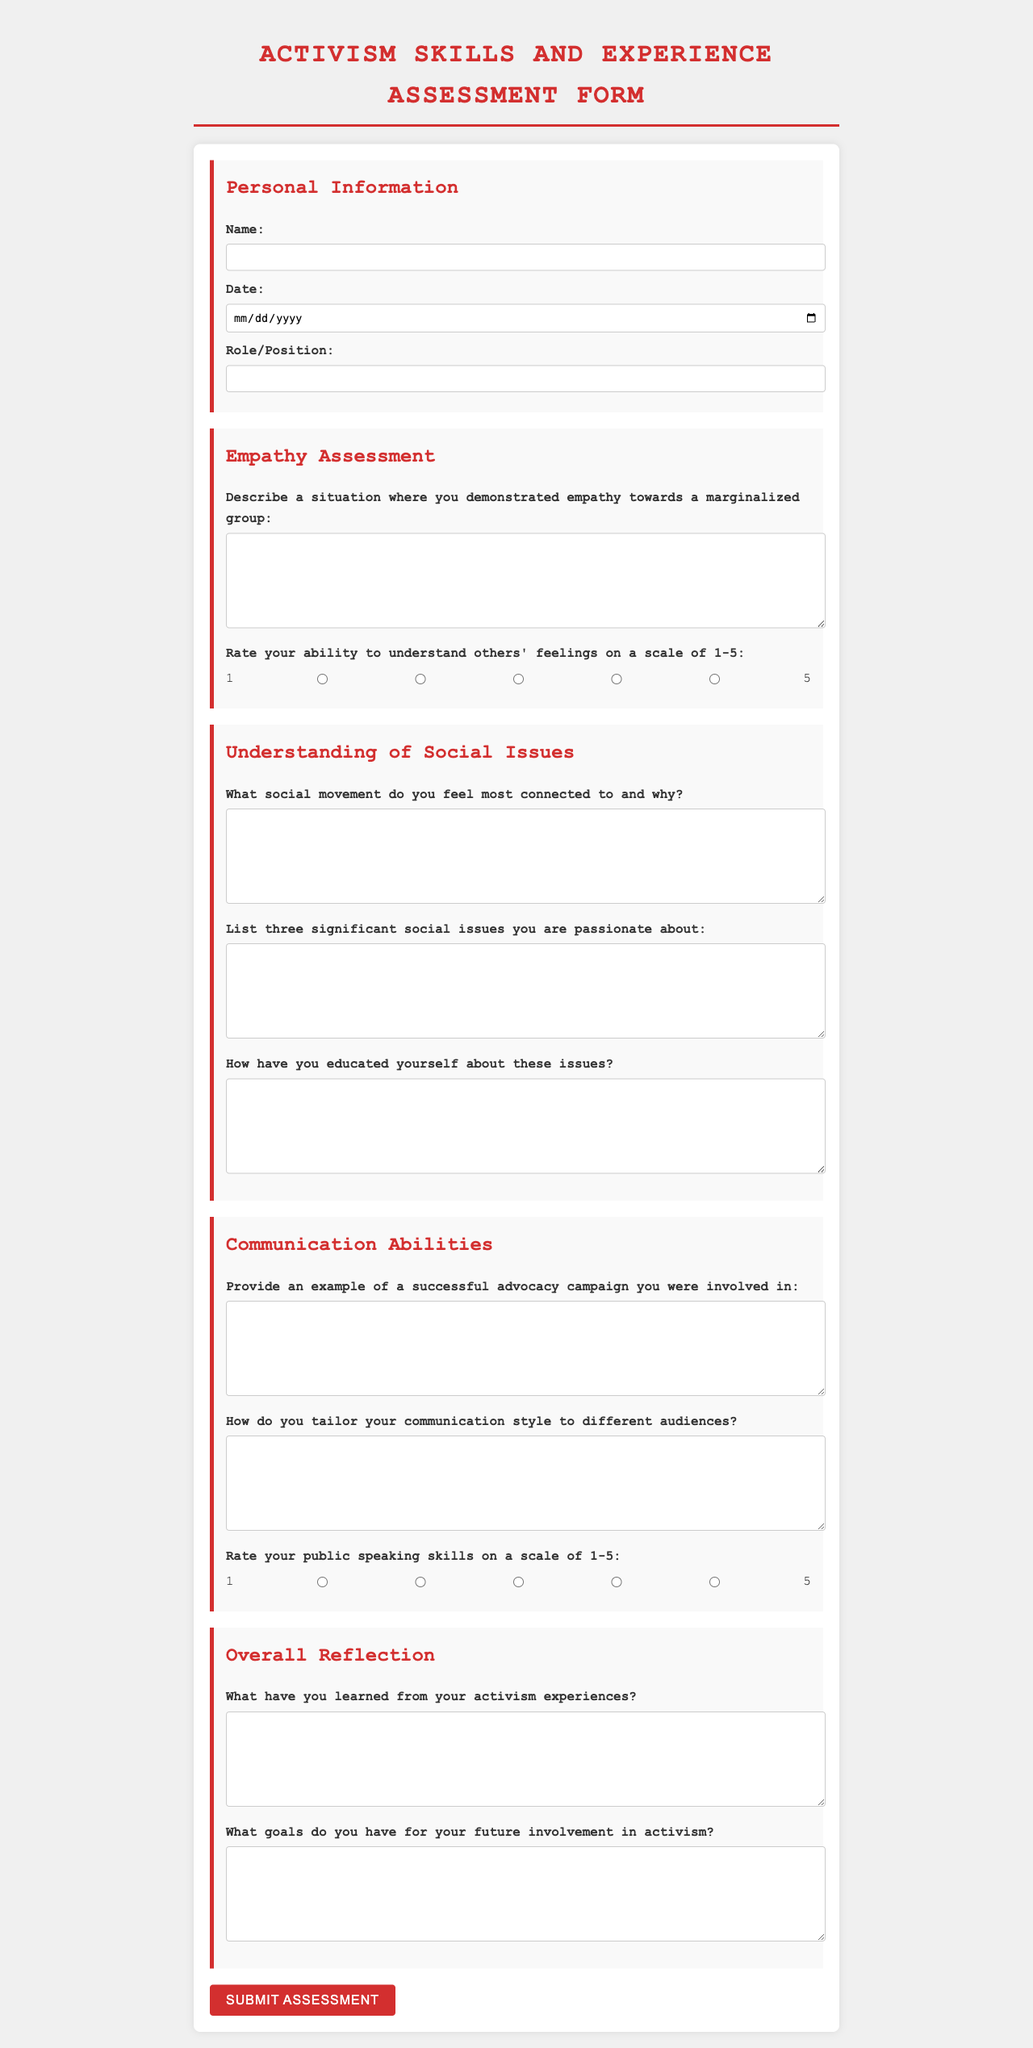What is the title of the document? The title of the document is displayed prominently at the top of the form.
Answer: Activism Skills and Experience Assessment Form How many sections are there in the form? The form is divided into multiple sections, each addressing different topics related to activism skills.
Answer: 4 What scale is used to rate empathy skills? The scale provided in the document is used for respondents to evaluate their ability in a specific area on a numerical basis.
Answer: 1-5 What date field is required in the Personal Information section? The date field is specified to gather important information for the assessment document.
Answer: Date What is one of the key questions in the Communication Abilities section? The question specifically asks for an example of practical experience in advocacy, showing participation in successful campaigns.
Answer: Provide an example of a successful advocacy campaign you were involved in What is required in the Understanding of Social Issues section? This part asks for respondents to express their connection and knowledge regarding social movements and issues.
Answer: List three significant social issues you are passionate about What color is used for headings in the document? The color coding in the document is used to maintain consistency and visually delineate sections.
Answer: Red What style of font is used in the document? The document specifies a particular font style that influences the overall readability and visual appearance.
Answer: Courier New 